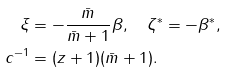Convert formula to latex. <formula><loc_0><loc_0><loc_500><loc_500>\xi & = - \frac { \bar { m } } { \bar { m } + 1 } \beta , \quad \zeta ^ { \ast } = - \beta ^ { \ast } , \\ c ^ { - 1 } & = ( z + 1 ) ( \bar { m } + 1 ) .</formula> 